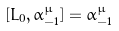<formula> <loc_0><loc_0><loc_500><loc_500>[ L _ { 0 } , \alpha ^ { \mu } _ { - 1 } ] = \alpha ^ { \mu } _ { - 1 }</formula> 